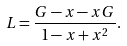<formula> <loc_0><loc_0><loc_500><loc_500>L = \frac { G - x - x G } { 1 - x + x ^ { 2 } } .</formula> 